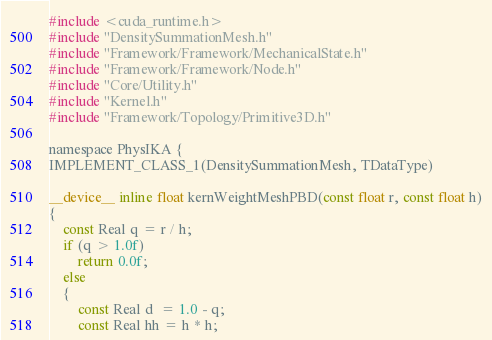<code> <loc_0><loc_0><loc_500><loc_500><_Cuda_>#include <cuda_runtime.h>
#include "DensitySummationMesh.h"
#include "Framework/Framework/MechanicalState.h"
#include "Framework/Framework/Node.h"
#include "Core/Utility.h"
#include "Kernel.h"
#include "Framework/Topology/Primitive3D.h"

namespace PhysIKA {
IMPLEMENT_CLASS_1(DensitySummationMesh, TDataType)

__device__ inline float kernWeightMeshPBD(const float r, const float h)
{
    const Real q = r / h;
    if (q > 1.0f)
        return 0.0f;
    else
    {
        const Real d  = 1.0 - q;
        const Real hh = h * h;</code> 